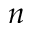Convert formula to latex. <formula><loc_0><loc_0><loc_500><loc_500>n</formula> 